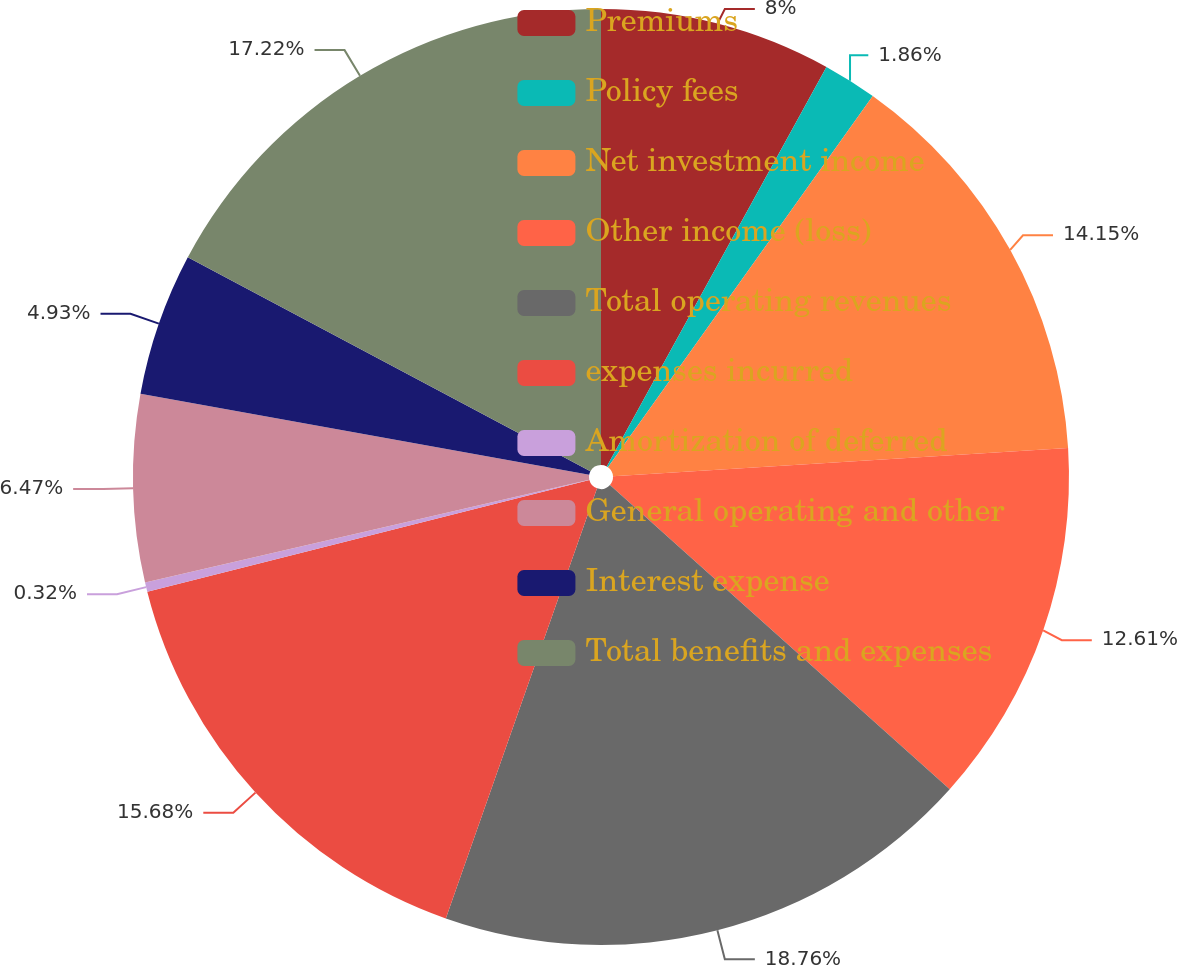Convert chart to OTSL. <chart><loc_0><loc_0><loc_500><loc_500><pie_chart><fcel>Premiums<fcel>Policy fees<fcel>Net investment income<fcel>Other income (loss)<fcel>Total operating revenues<fcel>expenses incurred<fcel>Amortization of deferred<fcel>General operating and other<fcel>Interest expense<fcel>Total benefits and expenses<nl><fcel>8.0%<fcel>1.86%<fcel>14.15%<fcel>12.61%<fcel>18.76%<fcel>15.68%<fcel>0.32%<fcel>6.47%<fcel>4.93%<fcel>17.22%<nl></chart> 